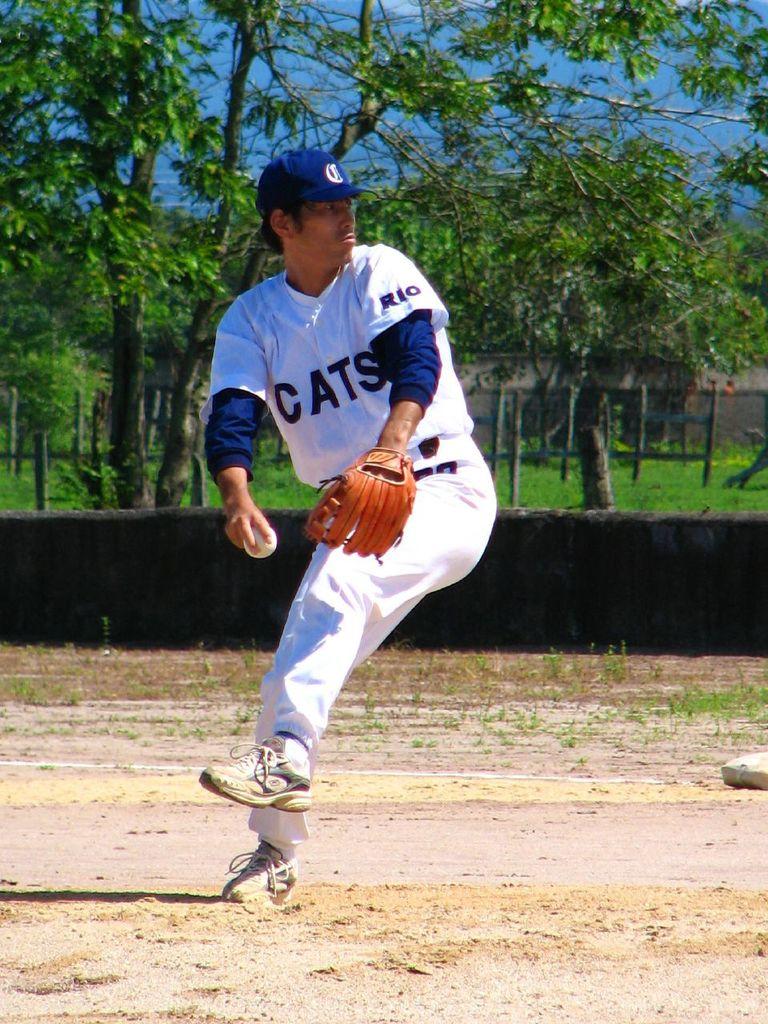What baseball team is that?
Your response must be concise. Cats. What letter is on his hat?
Offer a terse response. C. 